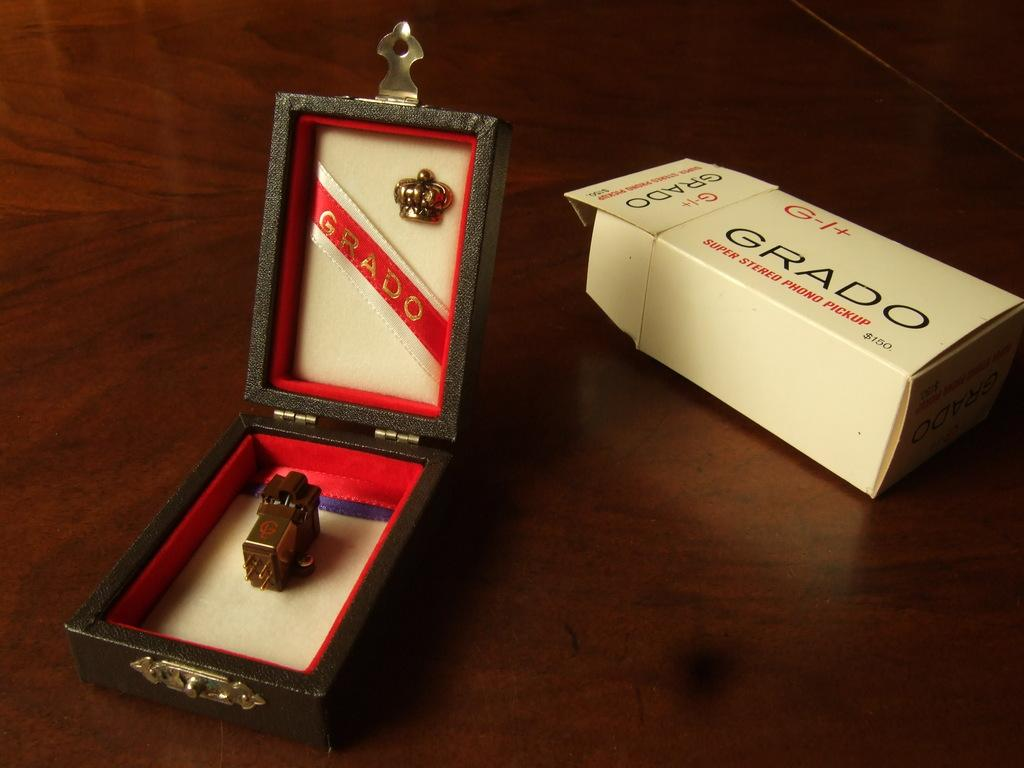<image>
Write a terse but informative summary of the picture. A white box from Grado is to the right of an open box with a metallic item in it. 